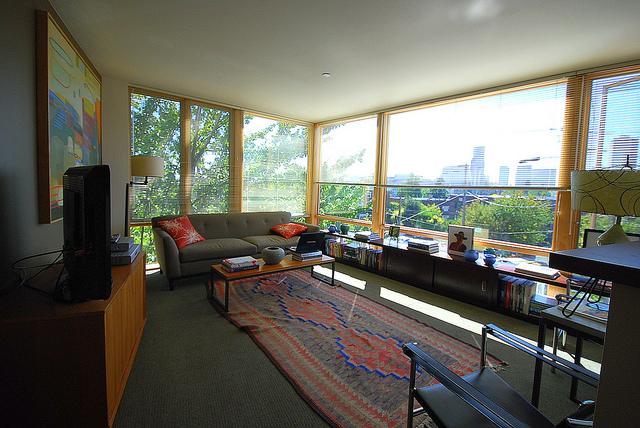Is this room a living room?
Answer briefly. Yes. In what environment would you most likely find a house like this?
Write a very short answer. City. How many windows are there?
Write a very short answer. 6. How long is the rug?
Be succinct. Long. IS the floor shiny?
Concise answer only. No. What room of the house is this?
Write a very short answer. Living room. Why is the television turned off?
Be succinct. No one is watching. What kind of flooring is this?
Concise answer only. Carpet. Is having several windows energy efficient?
Write a very short answer. Yes. 